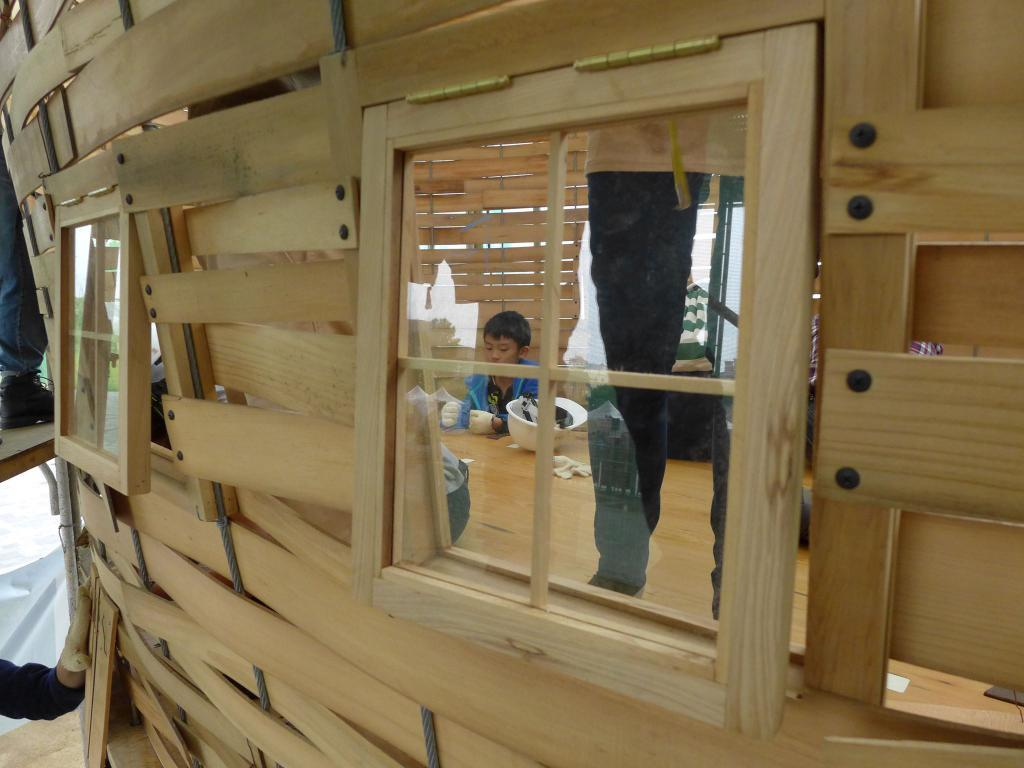Who is the main subject in the image? There is a child in the image. What can be seen in the background of the image? There are windows in the image. What type of structure is visible in the image? There is a wooden structure in the image. What type of jellyfish can be seen swimming in the garden in the image? There is no jellyfish or garden present in the image. 